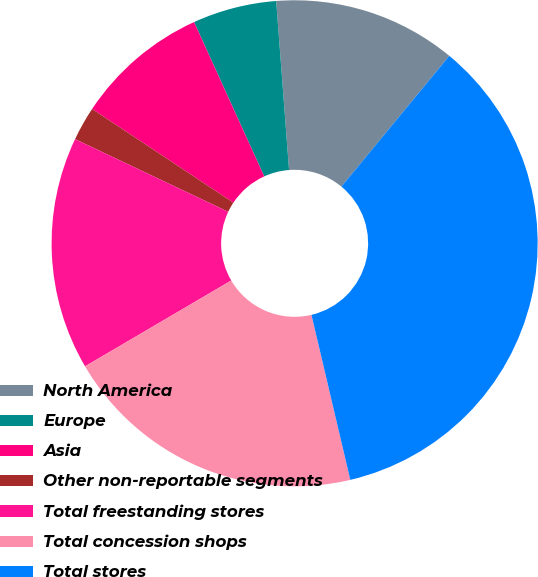<chart> <loc_0><loc_0><loc_500><loc_500><pie_chart><fcel>North America<fcel>Europe<fcel>Asia<fcel>Other non-reportable segments<fcel>Total freestanding stores<fcel>Total concession shops<fcel>Total stores<nl><fcel>12.19%<fcel>5.58%<fcel>8.89%<fcel>2.27%<fcel>15.5%<fcel>20.23%<fcel>35.34%<nl></chart> 